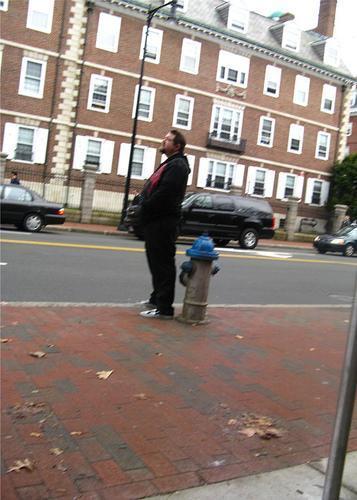How many people are there?
Give a very brief answer. 1. 